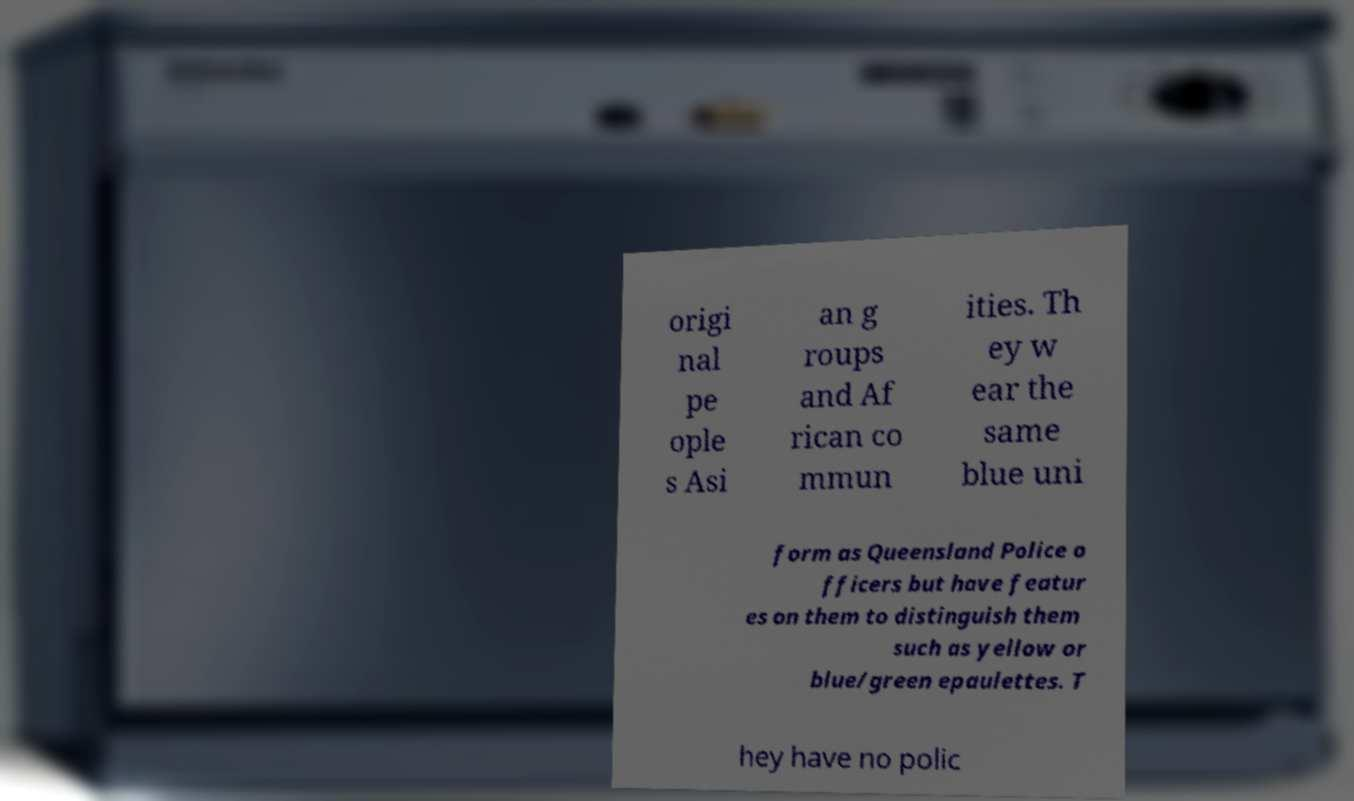Please read and relay the text visible in this image. What does it say? origi nal pe ople s Asi an g roups and Af rican co mmun ities. Th ey w ear the same blue uni form as Queensland Police o fficers but have featur es on them to distinguish them such as yellow or blue/green epaulettes. T hey have no polic 